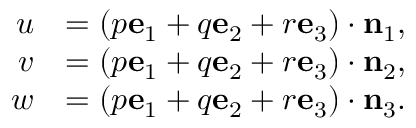Convert formula to latex. <formula><loc_0><loc_0><loc_500><loc_500>{ \begin{array} { r l } { u } & { = ( p e _ { 1 } + q e _ { 2 } + r e _ { 3 } ) \cdot n _ { 1 } , } \\ { v } & { = ( p e _ { 1 } + q e _ { 2 } + r e _ { 3 } ) \cdot n _ { 2 } , } \\ { w } & { = ( p e _ { 1 } + q e _ { 2 } + r e _ { 3 } ) \cdot n _ { 3 } . } \end{array} }</formula> 